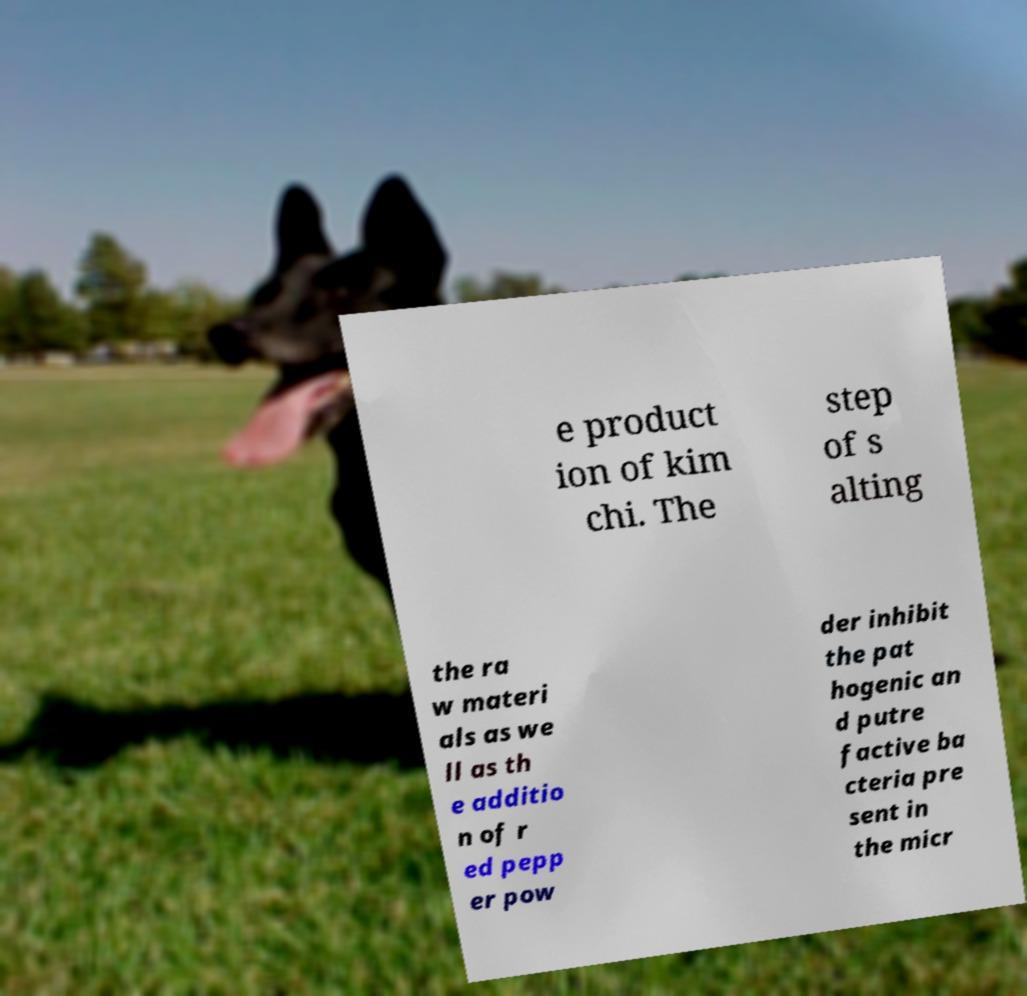There's text embedded in this image that I need extracted. Can you transcribe it verbatim? e product ion of kim chi. The step of s alting the ra w materi als as we ll as th e additio n of r ed pepp er pow der inhibit the pat hogenic an d putre factive ba cteria pre sent in the micr 